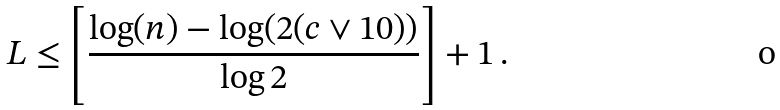<formula> <loc_0><loc_0><loc_500><loc_500>L \leq \left [ \frac { \log ( n ) - \log ( 2 ( c \vee 1 0 ) ) } { \log 2 } \right ] + 1 \, .</formula> 